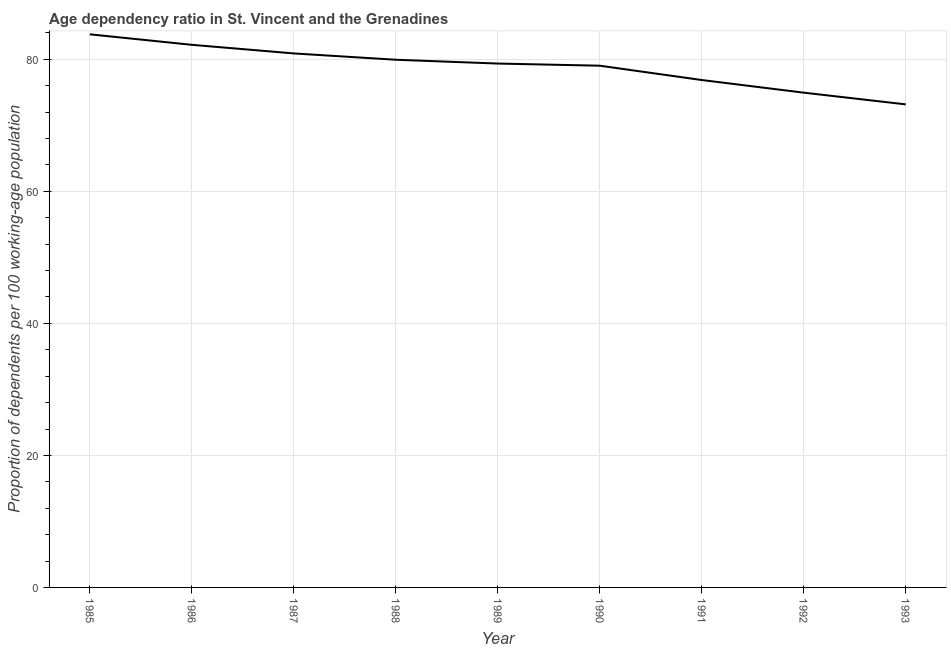What is the age dependency ratio in 1987?
Your answer should be very brief. 80.89. Across all years, what is the maximum age dependency ratio?
Your answer should be very brief. 83.79. Across all years, what is the minimum age dependency ratio?
Provide a succinct answer. 73.18. In which year was the age dependency ratio maximum?
Provide a succinct answer. 1985. What is the sum of the age dependency ratio?
Give a very brief answer. 710.22. What is the difference between the age dependency ratio in 1988 and 1989?
Provide a succinct answer. 0.58. What is the average age dependency ratio per year?
Your answer should be very brief. 78.91. What is the median age dependency ratio?
Ensure brevity in your answer.  79.36. Do a majority of the years between 1990 and 1991 (inclusive) have age dependency ratio greater than 36 ?
Your response must be concise. Yes. What is the ratio of the age dependency ratio in 1986 to that in 1987?
Make the answer very short. 1.02. Is the age dependency ratio in 1988 less than that in 1990?
Your answer should be compact. No. What is the difference between the highest and the second highest age dependency ratio?
Offer a terse response. 1.59. Is the sum of the age dependency ratio in 1988 and 1992 greater than the maximum age dependency ratio across all years?
Your answer should be compact. Yes. What is the difference between the highest and the lowest age dependency ratio?
Your response must be concise. 10.61. How many years are there in the graph?
Your answer should be compact. 9. Does the graph contain any zero values?
Your answer should be compact. No. What is the title of the graph?
Keep it short and to the point. Age dependency ratio in St. Vincent and the Grenadines. What is the label or title of the X-axis?
Offer a very short reply. Year. What is the label or title of the Y-axis?
Your answer should be very brief. Proportion of dependents per 100 working-age population. What is the Proportion of dependents per 100 working-age population in 1985?
Provide a short and direct response. 83.79. What is the Proportion of dependents per 100 working-age population of 1986?
Give a very brief answer. 82.2. What is the Proportion of dependents per 100 working-age population in 1987?
Provide a succinct answer. 80.89. What is the Proportion of dependents per 100 working-age population in 1988?
Offer a terse response. 79.94. What is the Proportion of dependents per 100 working-age population in 1989?
Your answer should be compact. 79.36. What is the Proportion of dependents per 100 working-age population in 1990?
Provide a succinct answer. 79.04. What is the Proportion of dependents per 100 working-age population in 1991?
Your answer should be compact. 76.87. What is the Proportion of dependents per 100 working-age population in 1992?
Offer a terse response. 74.95. What is the Proportion of dependents per 100 working-age population in 1993?
Ensure brevity in your answer.  73.18. What is the difference between the Proportion of dependents per 100 working-age population in 1985 and 1986?
Your answer should be very brief. 1.59. What is the difference between the Proportion of dependents per 100 working-age population in 1985 and 1987?
Ensure brevity in your answer.  2.9. What is the difference between the Proportion of dependents per 100 working-age population in 1985 and 1988?
Provide a succinct answer. 3.85. What is the difference between the Proportion of dependents per 100 working-age population in 1985 and 1989?
Your response must be concise. 4.43. What is the difference between the Proportion of dependents per 100 working-age population in 1985 and 1990?
Provide a succinct answer. 4.75. What is the difference between the Proportion of dependents per 100 working-age population in 1985 and 1991?
Ensure brevity in your answer.  6.92. What is the difference between the Proportion of dependents per 100 working-age population in 1985 and 1992?
Your response must be concise. 8.84. What is the difference between the Proportion of dependents per 100 working-age population in 1985 and 1993?
Your answer should be compact. 10.61. What is the difference between the Proportion of dependents per 100 working-age population in 1986 and 1987?
Your answer should be compact. 1.31. What is the difference between the Proportion of dependents per 100 working-age population in 1986 and 1988?
Provide a succinct answer. 2.26. What is the difference between the Proportion of dependents per 100 working-age population in 1986 and 1989?
Make the answer very short. 2.84. What is the difference between the Proportion of dependents per 100 working-age population in 1986 and 1990?
Ensure brevity in your answer.  3.16. What is the difference between the Proportion of dependents per 100 working-age population in 1986 and 1991?
Offer a very short reply. 5.33. What is the difference between the Proportion of dependents per 100 working-age population in 1986 and 1992?
Your answer should be very brief. 7.25. What is the difference between the Proportion of dependents per 100 working-age population in 1986 and 1993?
Give a very brief answer. 9.02. What is the difference between the Proportion of dependents per 100 working-age population in 1987 and 1988?
Keep it short and to the point. 0.96. What is the difference between the Proportion of dependents per 100 working-age population in 1987 and 1989?
Your answer should be compact. 1.53. What is the difference between the Proportion of dependents per 100 working-age population in 1987 and 1990?
Provide a short and direct response. 1.86. What is the difference between the Proportion of dependents per 100 working-age population in 1987 and 1991?
Ensure brevity in your answer.  4.03. What is the difference between the Proportion of dependents per 100 working-age population in 1987 and 1992?
Your answer should be compact. 5.94. What is the difference between the Proportion of dependents per 100 working-age population in 1987 and 1993?
Provide a succinct answer. 7.71. What is the difference between the Proportion of dependents per 100 working-age population in 1988 and 1989?
Provide a short and direct response. 0.58. What is the difference between the Proportion of dependents per 100 working-age population in 1988 and 1990?
Provide a succinct answer. 0.9. What is the difference between the Proportion of dependents per 100 working-age population in 1988 and 1991?
Make the answer very short. 3.07. What is the difference between the Proportion of dependents per 100 working-age population in 1988 and 1992?
Offer a very short reply. 4.99. What is the difference between the Proportion of dependents per 100 working-age population in 1988 and 1993?
Ensure brevity in your answer.  6.76. What is the difference between the Proportion of dependents per 100 working-age population in 1989 and 1990?
Ensure brevity in your answer.  0.33. What is the difference between the Proportion of dependents per 100 working-age population in 1989 and 1991?
Keep it short and to the point. 2.5. What is the difference between the Proportion of dependents per 100 working-age population in 1989 and 1992?
Provide a short and direct response. 4.41. What is the difference between the Proportion of dependents per 100 working-age population in 1989 and 1993?
Your answer should be compact. 6.18. What is the difference between the Proportion of dependents per 100 working-age population in 1990 and 1991?
Make the answer very short. 2.17. What is the difference between the Proportion of dependents per 100 working-age population in 1990 and 1992?
Offer a very short reply. 4.08. What is the difference between the Proportion of dependents per 100 working-age population in 1990 and 1993?
Keep it short and to the point. 5.86. What is the difference between the Proportion of dependents per 100 working-age population in 1991 and 1992?
Give a very brief answer. 1.92. What is the difference between the Proportion of dependents per 100 working-age population in 1991 and 1993?
Give a very brief answer. 3.69. What is the difference between the Proportion of dependents per 100 working-age population in 1992 and 1993?
Your answer should be compact. 1.77. What is the ratio of the Proportion of dependents per 100 working-age population in 1985 to that in 1986?
Your answer should be compact. 1.02. What is the ratio of the Proportion of dependents per 100 working-age population in 1985 to that in 1987?
Ensure brevity in your answer.  1.04. What is the ratio of the Proportion of dependents per 100 working-age population in 1985 to that in 1988?
Your response must be concise. 1.05. What is the ratio of the Proportion of dependents per 100 working-age population in 1985 to that in 1989?
Your answer should be compact. 1.06. What is the ratio of the Proportion of dependents per 100 working-age population in 1985 to that in 1990?
Offer a very short reply. 1.06. What is the ratio of the Proportion of dependents per 100 working-age population in 1985 to that in 1991?
Your answer should be very brief. 1.09. What is the ratio of the Proportion of dependents per 100 working-age population in 1985 to that in 1992?
Make the answer very short. 1.12. What is the ratio of the Proportion of dependents per 100 working-age population in 1985 to that in 1993?
Keep it short and to the point. 1.15. What is the ratio of the Proportion of dependents per 100 working-age population in 1986 to that in 1987?
Your answer should be compact. 1.02. What is the ratio of the Proportion of dependents per 100 working-age population in 1986 to that in 1988?
Offer a very short reply. 1.03. What is the ratio of the Proportion of dependents per 100 working-age population in 1986 to that in 1989?
Your answer should be very brief. 1.04. What is the ratio of the Proportion of dependents per 100 working-age population in 1986 to that in 1991?
Provide a succinct answer. 1.07. What is the ratio of the Proportion of dependents per 100 working-age population in 1986 to that in 1992?
Your answer should be compact. 1.1. What is the ratio of the Proportion of dependents per 100 working-age population in 1986 to that in 1993?
Keep it short and to the point. 1.12. What is the ratio of the Proportion of dependents per 100 working-age population in 1987 to that in 1988?
Offer a terse response. 1.01. What is the ratio of the Proportion of dependents per 100 working-age population in 1987 to that in 1990?
Your answer should be very brief. 1.02. What is the ratio of the Proportion of dependents per 100 working-age population in 1987 to that in 1991?
Your response must be concise. 1.05. What is the ratio of the Proportion of dependents per 100 working-age population in 1987 to that in 1992?
Your answer should be very brief. 1.08. What is the ratio of the Proportion of dependents per 100 working-age population in 1987 to that in 1993?
Offer a terse response. 1.1. What is the ratio of the Proportion of dependents per 100 working-age population in 1988 to that in 1990?
Your answer should be compact. 1.01. What is the ratio of the Proportion of dependents per 100 working-age population in 1988 to that in 1992?
Ensure brevity in your answer.  1.07. What is the ratio of the Proportion of dependents per 100 working-age population in 1988 to that in 1993?
Your answer should be very brief. 1.09. What is the ratio of the Proportion of dependents per 100 working-age population in 1989 to that in 1991?
Make the answer very short. 1.03. What is the ratio of the Proportion of dependents per 100 working-age population in 1989 to that in 1992?
Keep it short and to the point. 1.06. What is the ratio of the Proportion of dependents per 100 working-age population in 1989 to that in 1993?
Offer a terse response. 1.08. What is the ratio of the Proportion of dependents per 100 working-age population in 1990 to that in 1991?
Your answer should be compact. 1.03. What is the ratio of the Proportion of dependents per 100 working-age population in 1990 to that in 1992?
Make the answer very short. 1.05. What is the ratio of the Proportion of dependents per 100 working-age population in 1991 to that in 1992?
Your response must be concise. 1.03. What is the ratio of the Proportion of dependents per 100 working-age population in 1992 to that in 1993?
Your response must be concise. 1.02. 